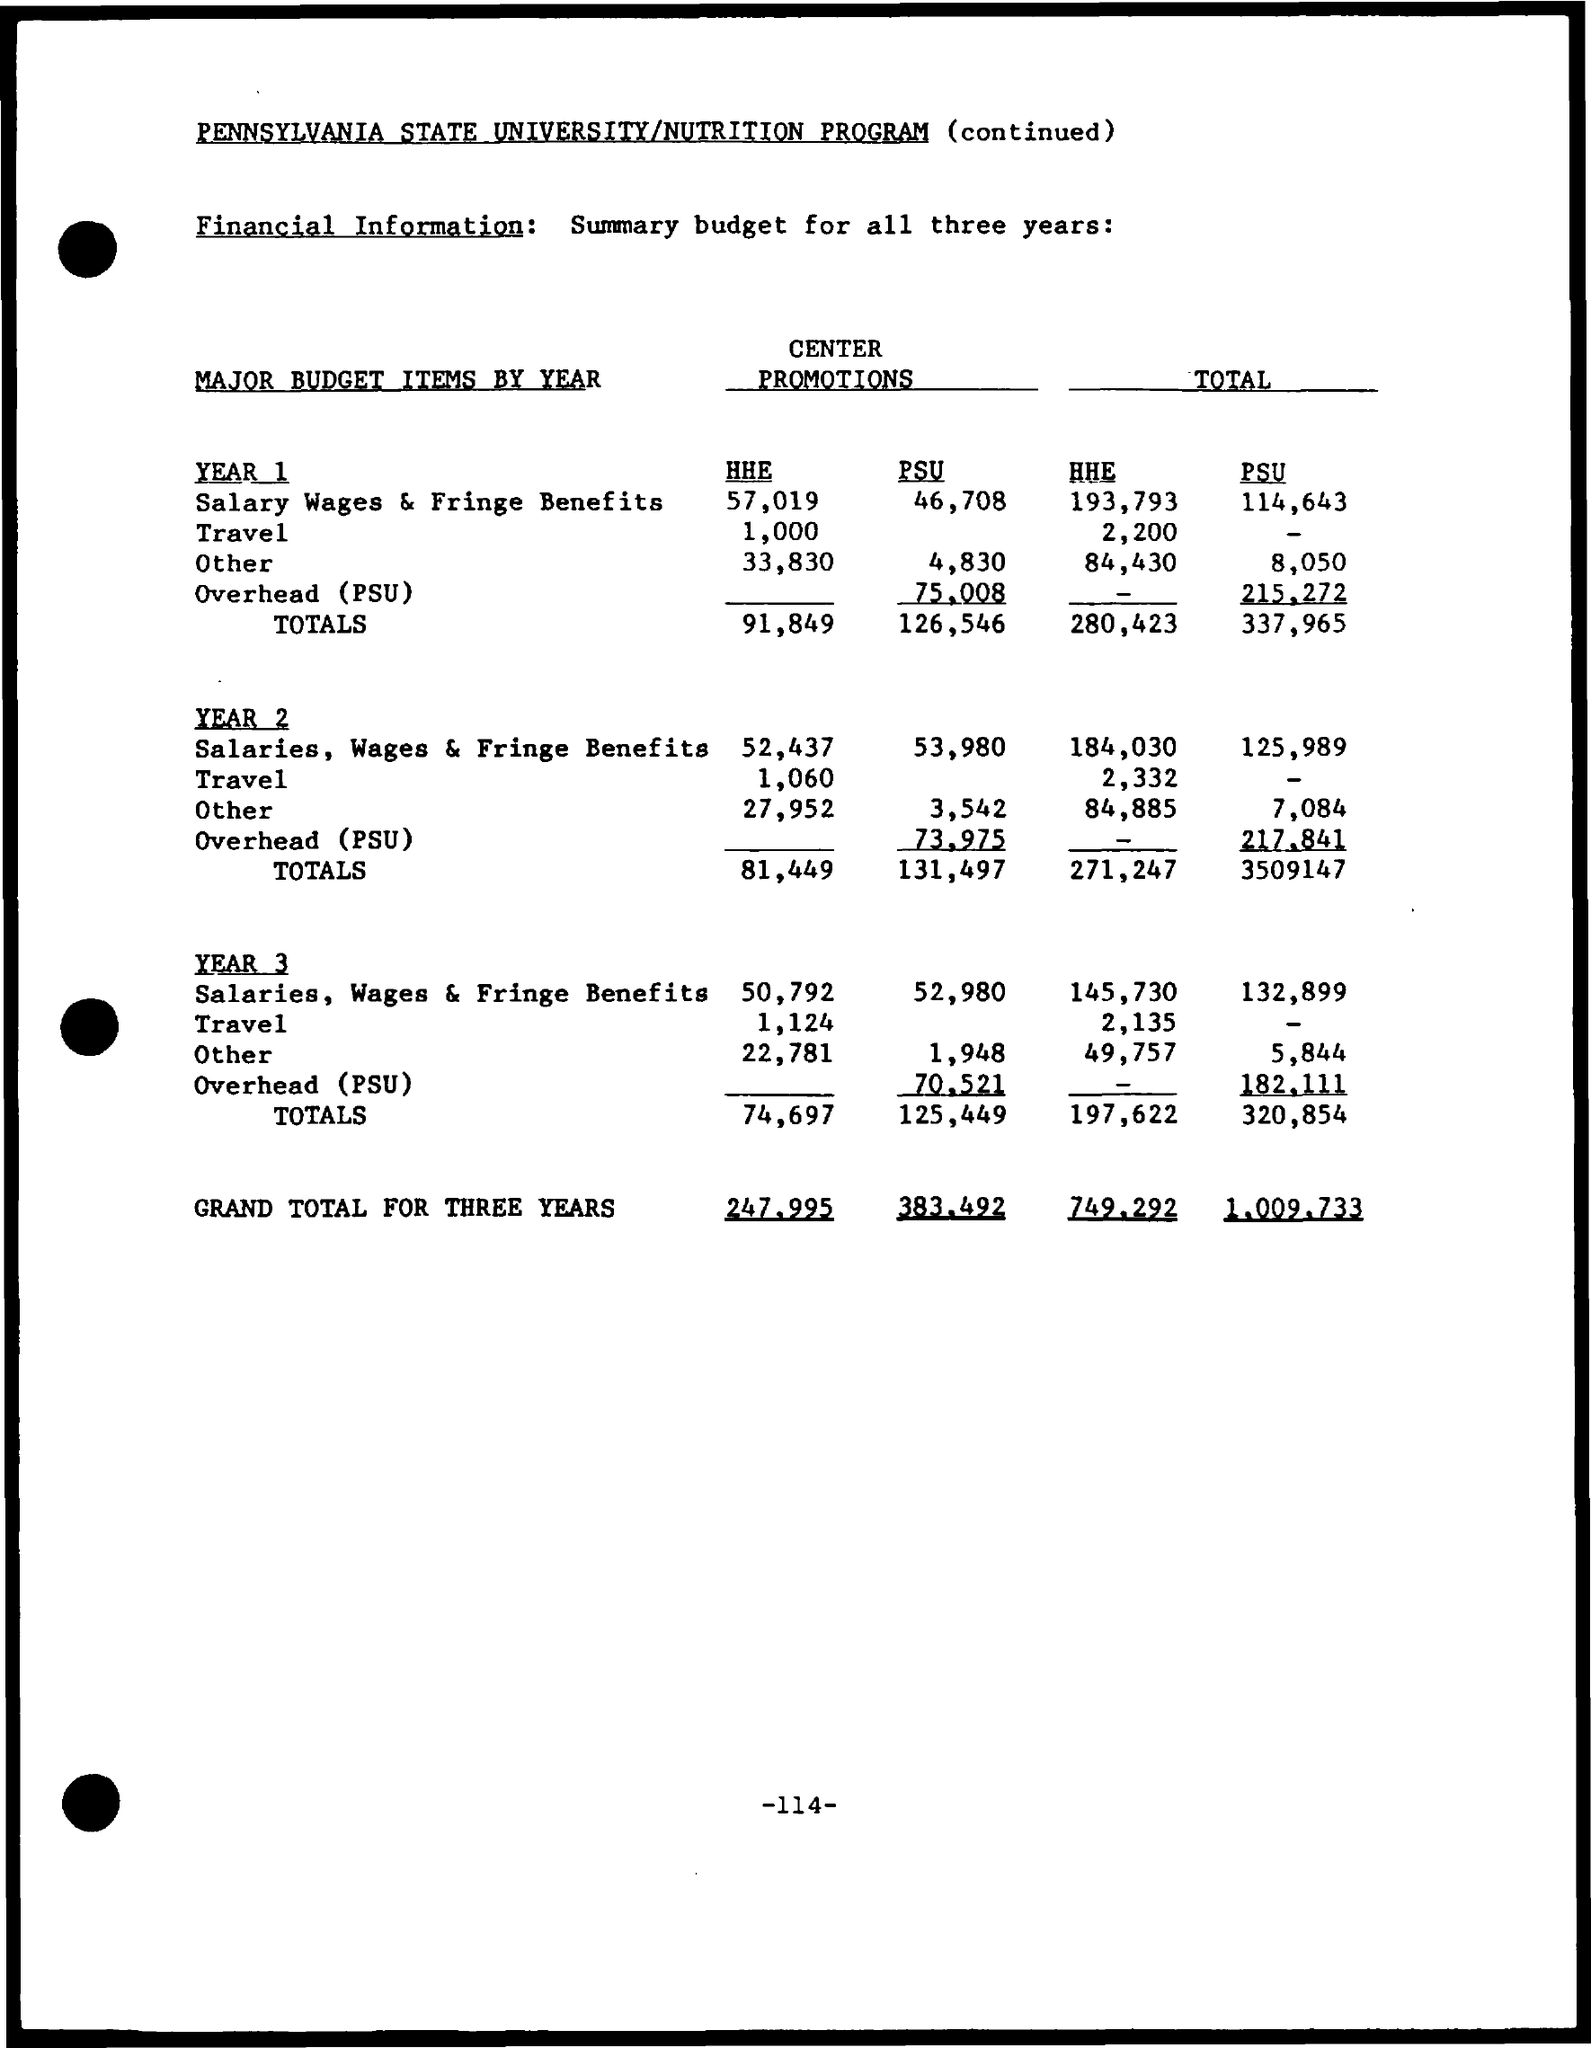What is the Total Salary wages & Fringe Benefits for HHE for Year 1?
Offer a very short reply. 193,793. What is the Total Salary wages & Fringe Benefits for PSU for Year 1?
Provide a succinct answer. 114,643. What is the Total Travel for HHE for Year 1?
Make the answer very short. 2,200. What is the Total Other expenses for HHE for Year 1?
Give a very brief answer. 84,430. What is the Total Other expenses for PSU for Year 1?
Give a very brief answer. 8,050. What is the Total Salary wages & Fringe Benefits for HHE for Year 2?
Your response must be concise. 184,030. What is the Total Salary wages & Fringe Benefits for PSU for Year 2?
Your response must be concise. 125,989. What is the Total Travel for HHE for Year 2?
Ensure brevity in your answer.  2,332. What is the Total Other expenses for HHE for Year 2?
Offer a very short reply. 84,885. What is the Total Other expenses for PSU for Year 2?
Offer a very short reply. 7,084. 